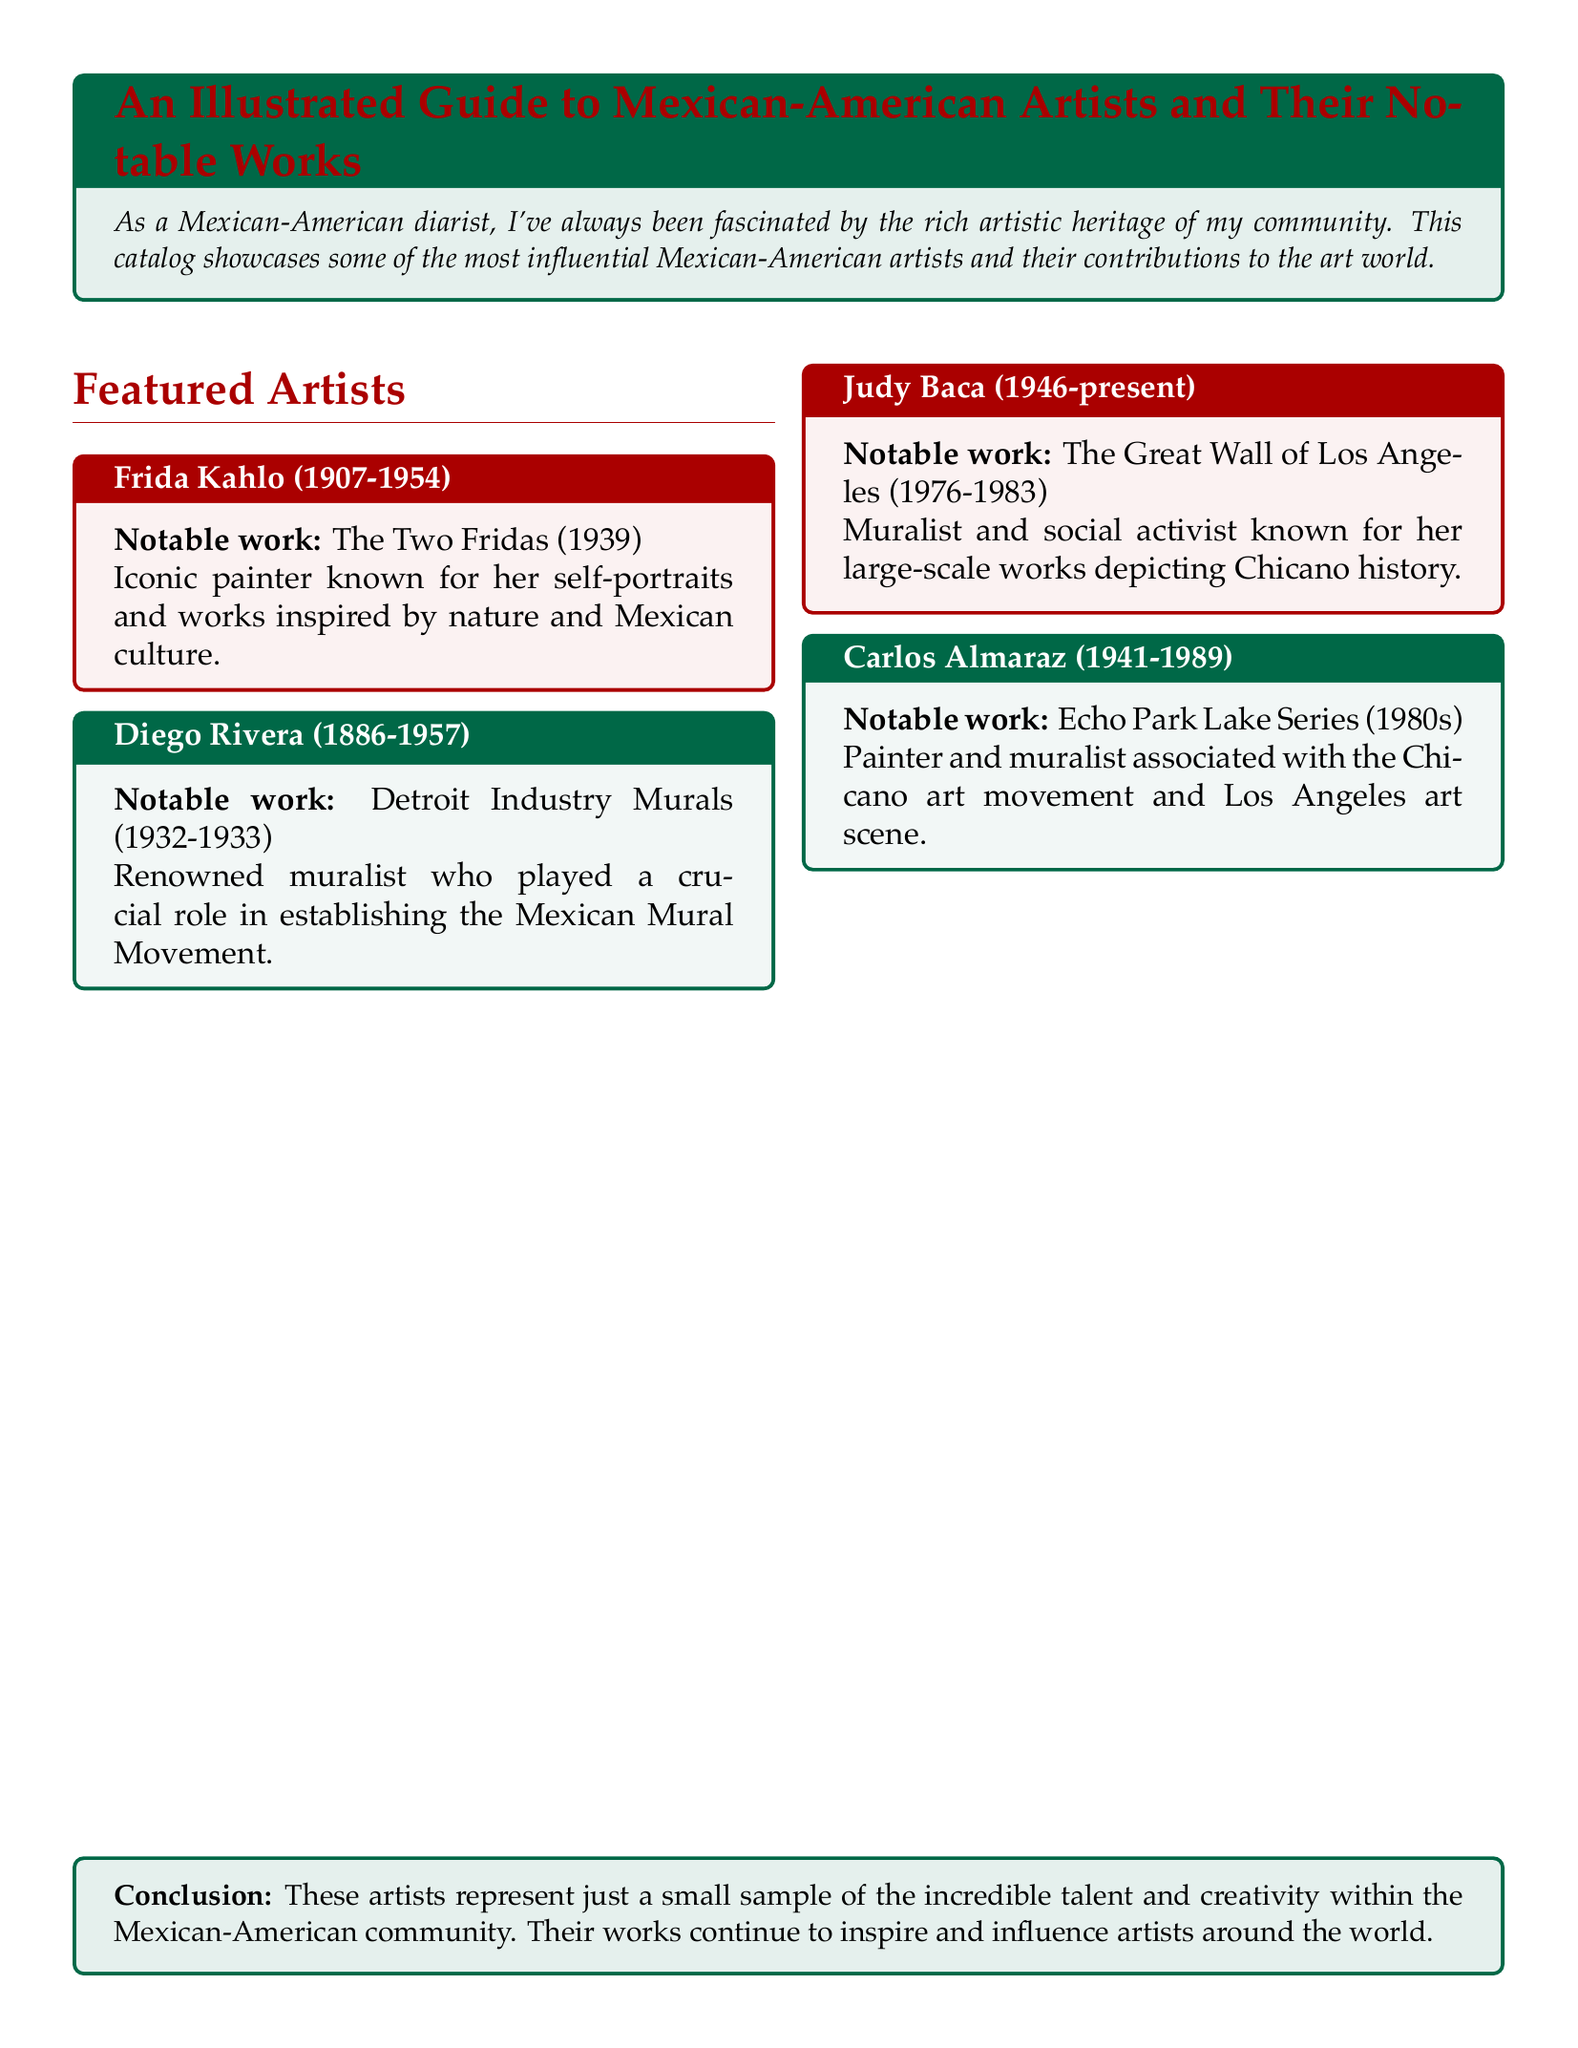What is the notable work of Frida Kahlo? The document specifically states the notable work of Frida Kahlo as "The Two Fridas (1939)."
Answer: The Two Fridas (1939) Who created the Detroit Industry Murals? The document mentions that Diego Rivera is the artist who created the "Detroit Industry Murals."
Answer: Diego Rivera In what year was The Great Wall of Los Angeles completed? The completion year is listed in the document as part of Judy Baca's notable work from "1976-1983."
Answer: 1983 How many artists are featured in the document? The document lists a total of four featured artists in its main section.
Answer: 4 Which artist is associated with the Echo Park Lake Series? Carlos Almaraz is mentioned as the artist associated with the "Echo Park Lake Series."
Answer: Carlos Almaraz What color is used for the section title in the document? The color defined for the section titles is "mexicanred."
Answer: mexicanred What is the primary theme in Judy Baca's artworks? The document states that Judy Baca's artworks depict "Chicano history," indicating her main theme.
Answer: Chicano history What style of art is Diego Rivera known for? The document describes Diego Rivera's major contribution as "muralist" and his role in the "Mexican Mural Movement."
Answer: Muralist What is the closing remark in the conclusion? The conclusion summarizes that the featured artists represent a "small sample" of talent within the community.
Answer: Small sample 